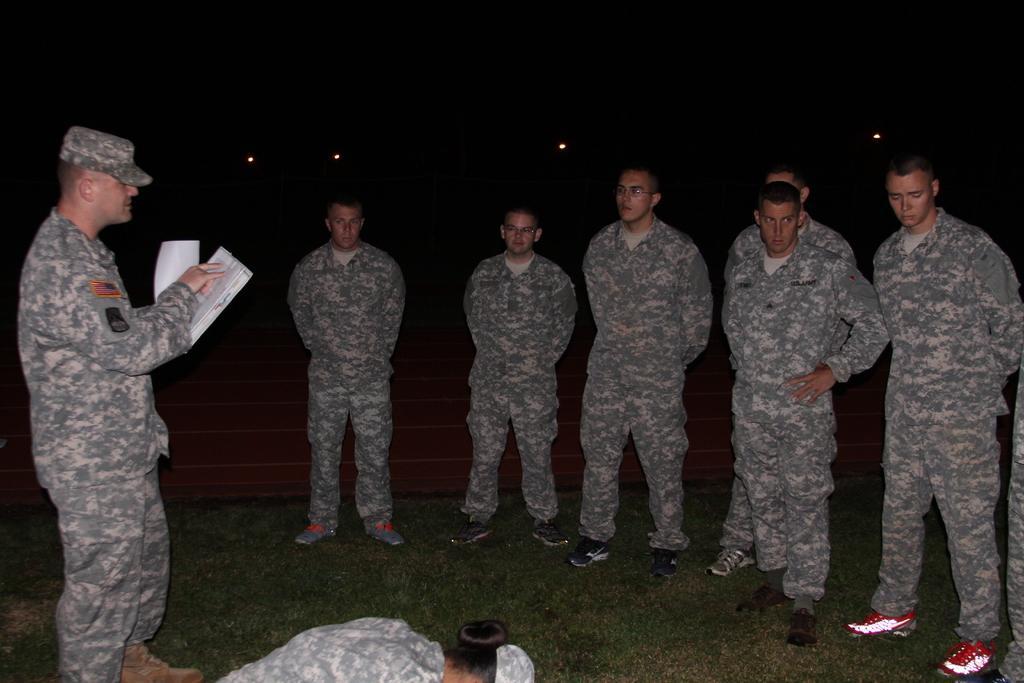Describe this image in one or two sentences. In this picture I can see group of people standing, a person holding papers, there are lights, and there is dark background. 